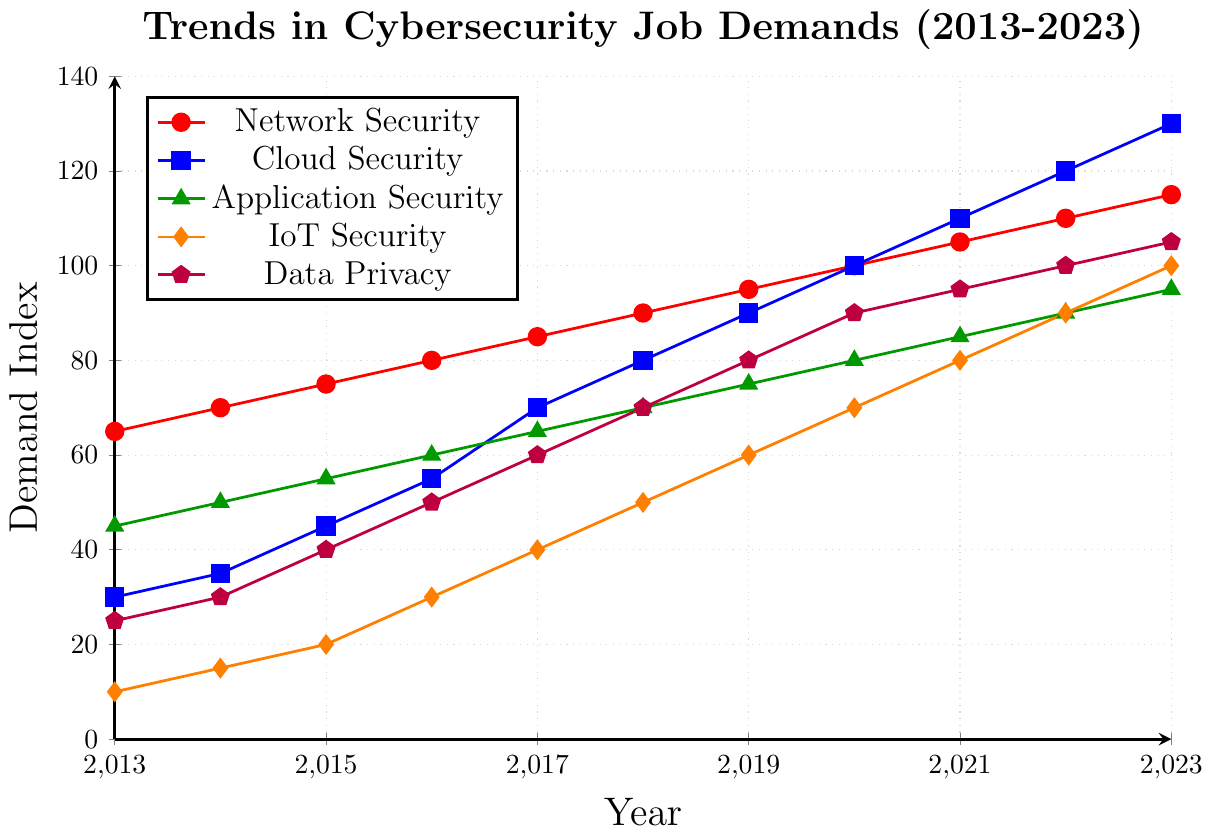What is the trend for Network Security job demands from 2013 to 2023? Network Security job demand increases steadily from 65 in 2013 to 115 in 2023, showing a consistent upward trend every year.
Answer: Upward trend Which IT sector has the highest job demand in 2023? In 2023, Cloud Security has the highest job demand, shown by the blue line reaching 130.
Answer: Cloud Security By how much did IoT Security job demands increase from 2013 to 2023? IoT Security job demand increased from 10 in 2013 to 100 in 2023. The difference is 100 - 10 = 90.
Answer: 90 Between Data Privacy and Application Security in 2020, which had the higher job demand? In 2020, Data Privacy (shown in purple) reached 90, whereas Application Security (shown in green) was at 80. Hence, Data Privacy had higher job demand.
Answer: Data Privacy What is the average job demand for Cloud Security in 2018 and 2022? The job demand for Cloud Security was 80 in 2018 and 120 in 2022. The average is (80 + 120) / 2 = 100.
Answer: 100 In which year did IoT Security see the largest increase in job demand? IoT Security saw the largest increase between 2015 and 2016, where the demand increased from 20 to 30.
Answer: 2016 Compare the trends in job demands for Application Security and Data Privacy from 2013 to 2023. Both Application Security and Data Privacy show a steady increase in job demands over the years. However, Data Privacy (shown in purple) started lower and ended higher at 105 compared to Application Security's 95 (shown in green).
Answer: Data Privacy increased more What is the difference in job demand between Network Security and Cloud Security in 2023? In 2023, Network Security's job demand is 115 and Cloud Security's job demand is 130. The difference is 130 - 115 = 15.
Answer: 15 What is the color representation for the highest demanded IT sector in 2019? In 2019, Cloud Security had the highest job demand and is represented by the blue line.
Answer: Blue 